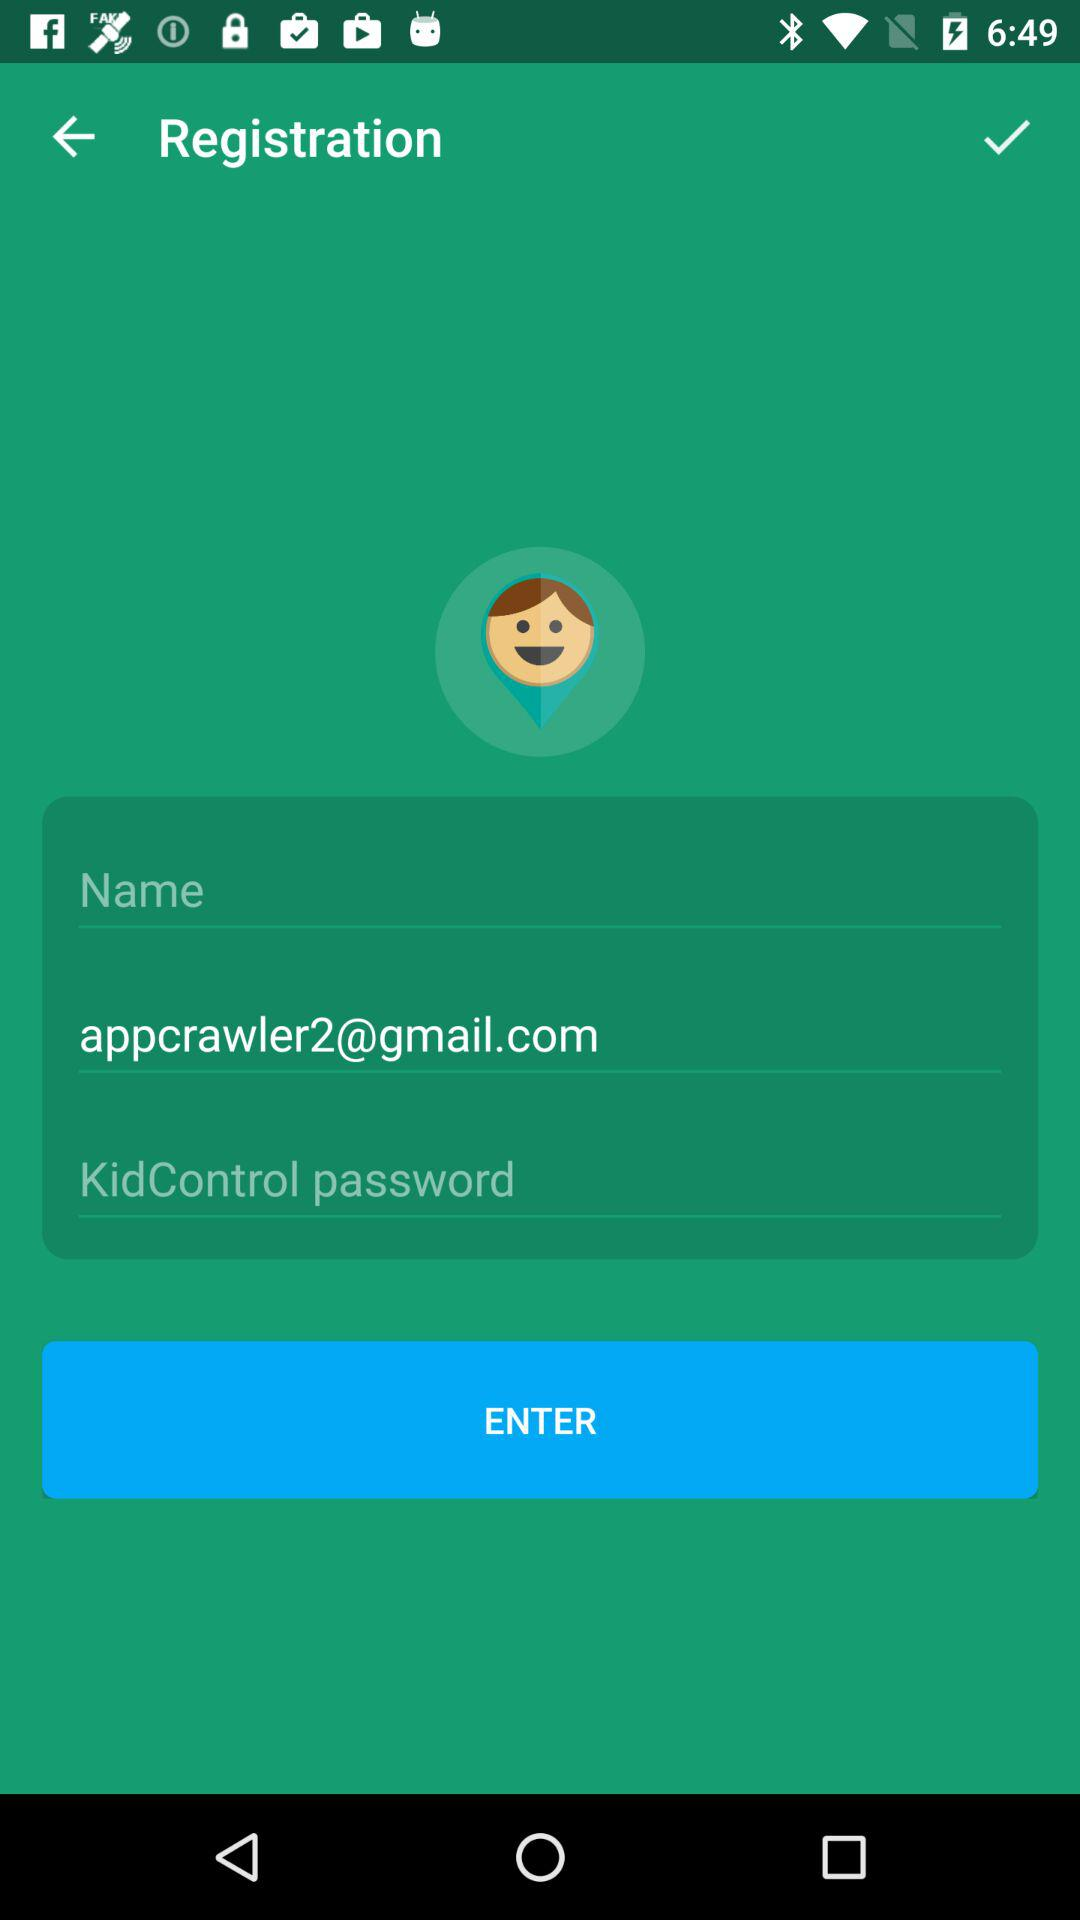How many text inputs are required to complete the registration form?
Answer the question using a single word or phrase. 3 